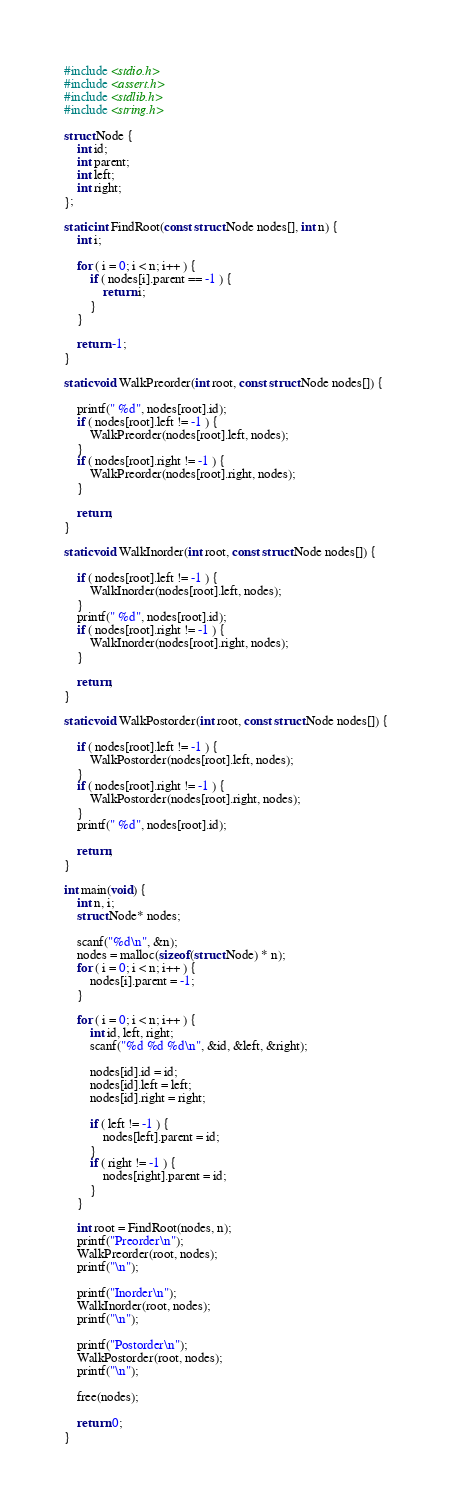<code> <loc_0><loc_0><loc_500><loc_500><_C_>#include <stdio.h>
#include <assert.h>
#include <stdlib.h>
#include <string.h>

struct Node {
    int id;
    int parent;
    int left;
    int right;
};

static int FindRoot(const struct Node nodes[], int n) {
    int i;

    for ( i = 0; i < n; i++ ) {
        if ( nodes[i].parent == -1 ) {
            return i;
        }
    }

    return -1;
}

static void WalkPreorder(int root, const struct Node nodes[]) {

    printf(" %d", nodes[root].id);
    if ( nodes[root].left != -1 ) {
        WalkPreorder(nodes[root].left, nodes);
    }
    if ( nodes[root].right != -1 ) {
        WalkPreorder(nodes[root].right, nodes);
    }

    return;
}

static void WalkInorder(int root, const struct Node nodes[]) {

    if ( nodes[root].left != -1 ) {
        WalkInorder(nodes[root].left, nodes);
    }
    printf(" %d", nodes[root].id);
    if ( nodes[root].right != -1 ) {
        WalkInorder(nodes[root].right, nodes);
    }

    return;
}

static void WalkPostorder(int root, const struct Node nodes[]) {

    if ( nodes[root].left != -1 ) {
        WalkPostorder(nodes[root].left, nodes);
    }
    if ( nodes[root].right != -1 ) {
        WalkPostorder(nodes[root].right, nodes);
    }
    printf(" %d", nodes[root].id);

    return;
}

int main(void) {
    int n, i;
    struct Node* nodes;

    scanf("%d\n", &n);
    nodes = malloc(sizeof(struct Node) * n);
    for ( i = 0; i < n; i++ ) {
        nodes[i].parent = -1;
    }

    for ( i = 0; i < n; i++ ) {
        int id, left, right;
        scanf("%d %d %d\n", &id, &left, &right);

        nodes[id].id = id;
        nodes[id].left = left;
        nodes[id].right = right;

        if ( left != -1 ) {
            nodes[left].parent = id;
        }
        if ( right != -1 ) {
            nodes[right].parent = id;
        }
    }

    int root = FindRoot(nodes, n);
    printf("Preorder\n");
    WalkPreorder(root, nodes);
    printf("\n");

    printf("Inorder\n");    
    WalkInorder(root, nodes);
    printf("\n");

    printf("Postorder\n");
    WalkPostorder(root, nodes);
    printf("\n");
    
    free(nodes);

    return 0;
}

</code> 